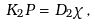Convert formula to latex. <formula><loc_0><loc_0><loc_500><loc_500>K _ { 2 } P = D _ { 2 } \chi \, ,</formula> 